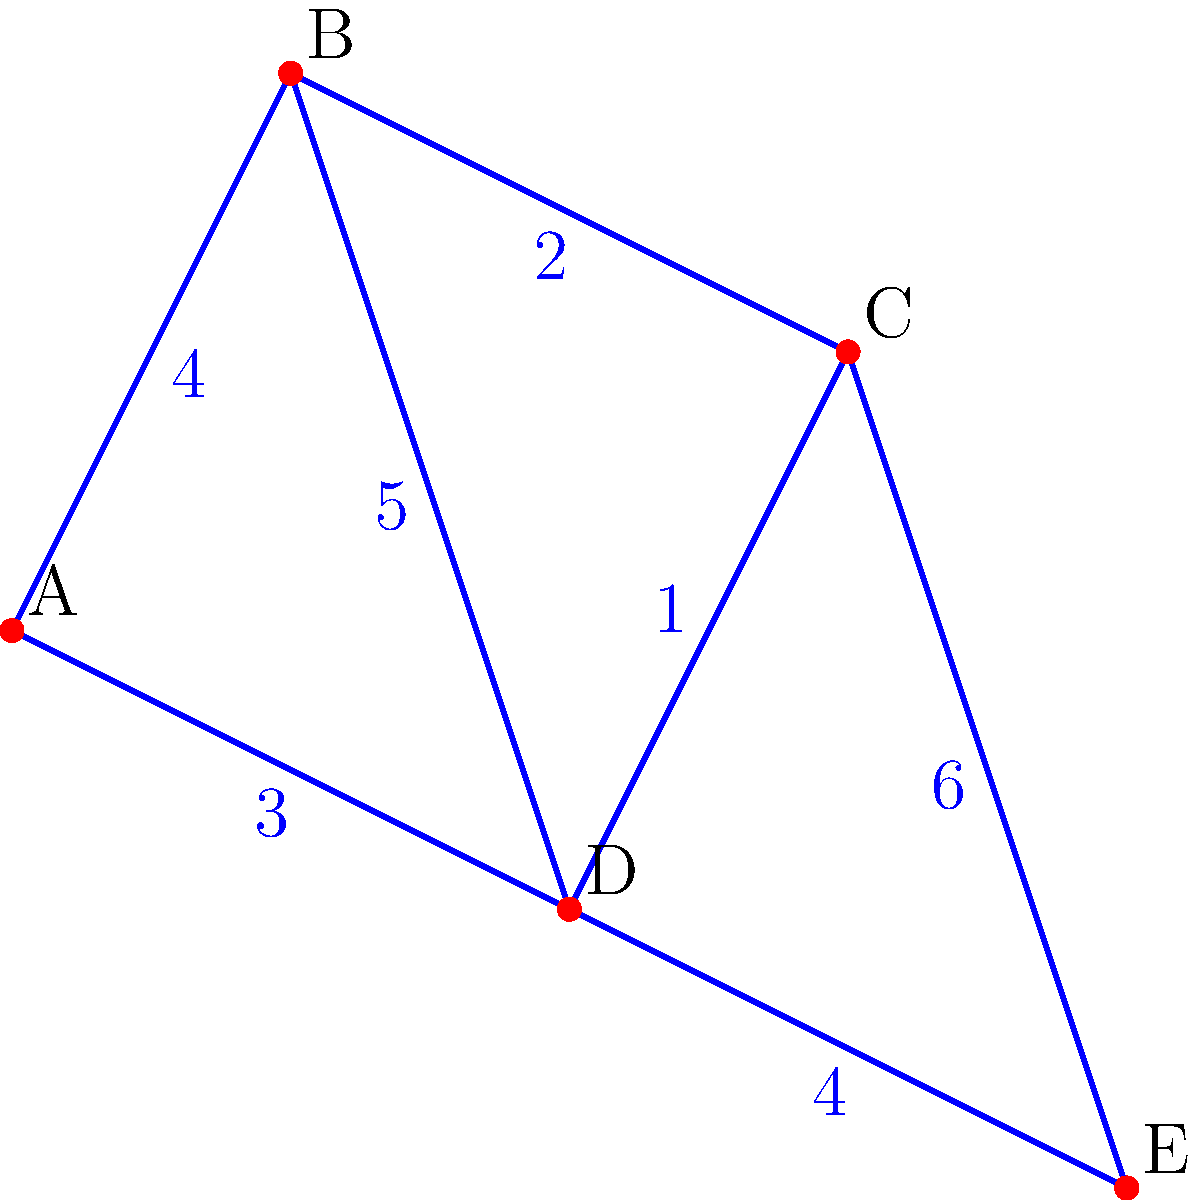Given the network of cities represented by the graph above, where each edge represents a road connecting two cities and the number on each edge represents the cost of constructing that road in millions of dollars, determine the minimum total cost to connect all cities with roads. Show your work by listing the edges in the minimum spanning tree and their corresponding costs. To find the minimum spanning tree and calculate the total cost, we'll use Kruskal's algorithm, which is an efficient method for finding the minimum spanning tree in a weighted, undirected graph. Let's proceed step-by-step:

1. Sort all edges by weight (cost) in ascending order:
   C-D: 1
   B-C: 2
   A-D: 3
   A-B: 4
   D-E: 4
   B-D: 5
   C-E: 6

2. Start with an empty set of edges for our minimum spanning tree (MST).

3. Iterate through the sorted edges, adding each edge to the MST if it doesn't create a cycle:

   a. Add C-D (cost: 1)
      MST edges: {C-D}
      Total cost: 1

   b. Add B-C (cost: 2)
      MST edges: {C-D, B-C}
      Total cost: 1 + 2 = 3

   c. Add A-D (cost: 3)
      MST edges: {C-D, B-C, A-D}
      Total cost: 1 + 2 + 3 = 6

   d. Skip A-B (would create a cycle)

   e. Add D-E (cost: 4)
      MST edges: {C-D, B-C, A-D, D-E}
      Total cost: 1 + 2 + 3 + 4 = 10

4. We now have a minimum spanning tree that connects all vertices (cities), so we stop.

The minimum spanning tree consists of the edges: C-D, B-C, A-D, and D-E.
The total cost is the sum of the costs of these edges: 1 + 2 + 3 + 4 = 10 million dollars.
Answer: $10 million 